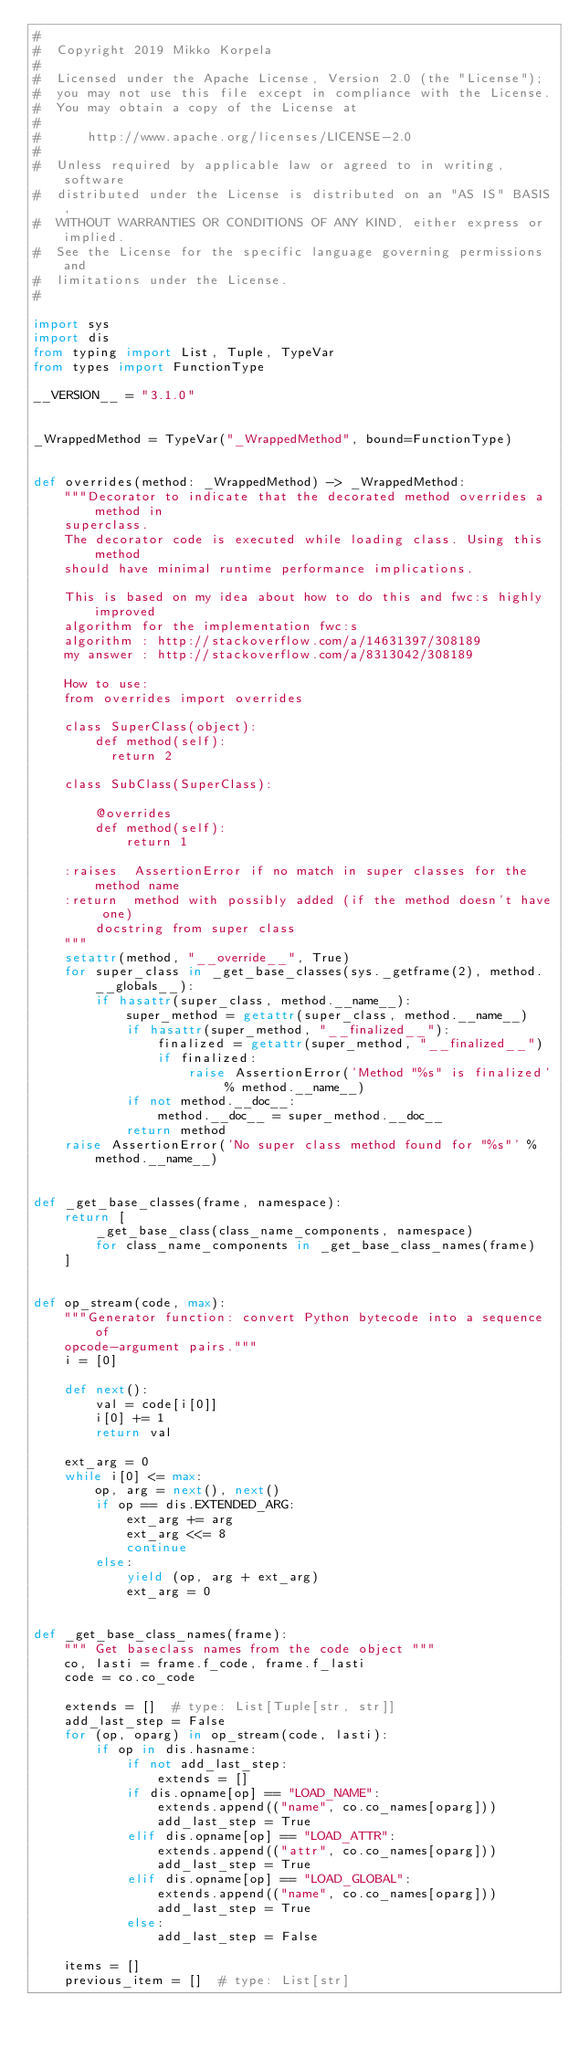Convert code to text. <code><loc_0><loc_0><loc_500><loc_500><_Python_>#
#  Copyright 2019 Mikko Korpela
#
#  Licensed under the Apache License, Version 2.0 (the "License");
#  you may not use this file except in compliance with the License.
#  You may obtain a copy of the License at
#
#      http://www.apache.org/licenses/LICENSE-2.0
#
#  Unless required by applicable law or agreed to in writing, software
#  distributed under the License is distributed on an "AS IS" BASIS,
#  WITHOUT WARRANTIES OR CONDITIONS OF ANY KIND, either express or implied.
#  See the License for the specific language governing permissions and
#  limitations under the License.
#

import sys
import dis
from typing import List, Tuple, TypeVar
from types import FunctionType

__VERSION__ = "3.1.0"


_WrappedMethod = TypeVar("_WrappedMethod", bound=FunctionType)


def overrides(method: _WrappedMethod) -> _WrappedMethod:
    """Decorator to indicate that the decorated method overrides a method in
    superclass.
    The decorator code is executed while loading class. Using this method
    should have minimal runtime performance implications.

    This is based on my idea about how to do this and fwc:s highly improved
    algorithm for the implementation fwc:s
    algorithm : http://stackoverflow.com/a/14631397/308189
    my answer : http://stackoverflow.com/a/8313042/308189

    How to use:
    from overrides import overrides

    class SuperClass(object):
        def method(self):
          return 2

    class SubClass(SuperClass):

        @overrides
        def method(self):
            return 1

    :raises  AssertionError if no match in super classes for the method name
    :return  method with possibly added (if the method doesn't have one)
        docstring from super class
    """
    setattr(method, "__override__", True)
    for super_class in _get_base_classes(sys._getframe(2), method.__globals__):
        if hasattr(super_class, method.__name__):
            super_method = getattr(super_class, method.__name__)
            if hasattr(super_method, "__finalized__"):
                finalized = getattr(super_method, "__finalized__")
                if finalized:
                    raise AssertionError('Method "%s" is finalized' % method.__name__)
            if not method.__doc__:
                method.__doc__ = super_method.__doc__
            return method
    raise AssertionError('No super class method found for "%s"' % method.__name__)


def _get_base_classes(frame, namespace):
    return [
        _get_base_class(class_name_components, namespace)
        for class_name_components in _get_base_class_names(frame)
    ]


def op_stream(code, max):
    """Generator function: convert Python bytecode into a sequence of
    opcode-argument pairs."""
    i = [0]

    def next():
        val = code[i[0]]
        i[0] += 1
        return val

    ext_arg = 0
    while i[0] <= max:
        op, arg = next(), next()
        if op == dis.EXTENDED_ARG:
            ext_arg += arg
            ext_arg <<= 8
            continue
        else:
            yield (op, arg + ext_arg)
            ext_arg = 0


def _get_base_class_names(frame):
    """ Get baseclass names from the code object """
    co, lasti = frame.f_code, frame.f_lasti
    code = co.co_code

    extends = []  # type: List[Tuple[str, str]]
    add_last_step = False
    for (op, oparg) in op_stream(code, lasti):
        if op in dis.hasname:
            if not add_last_step:
                extends = []
            if dis.opname[op] == "LOAD_NAME":
                extends.append(("name", co.co_names[oparg]))
                add_last_step = True
            elif dis.opname[op] == "LOAD_ATTR":
                extends.append(("attr", co.co_names[oparg]))
                add_last_step = True
            elif dis.opname[op] == "LOAD_GLOBAL":
                extends.append(("name", co.co_names[oparg]))
                add_last_step = True
            else:
                add_last_step = False

    items = []
    previous_item = []  # type: List[str]</code> 